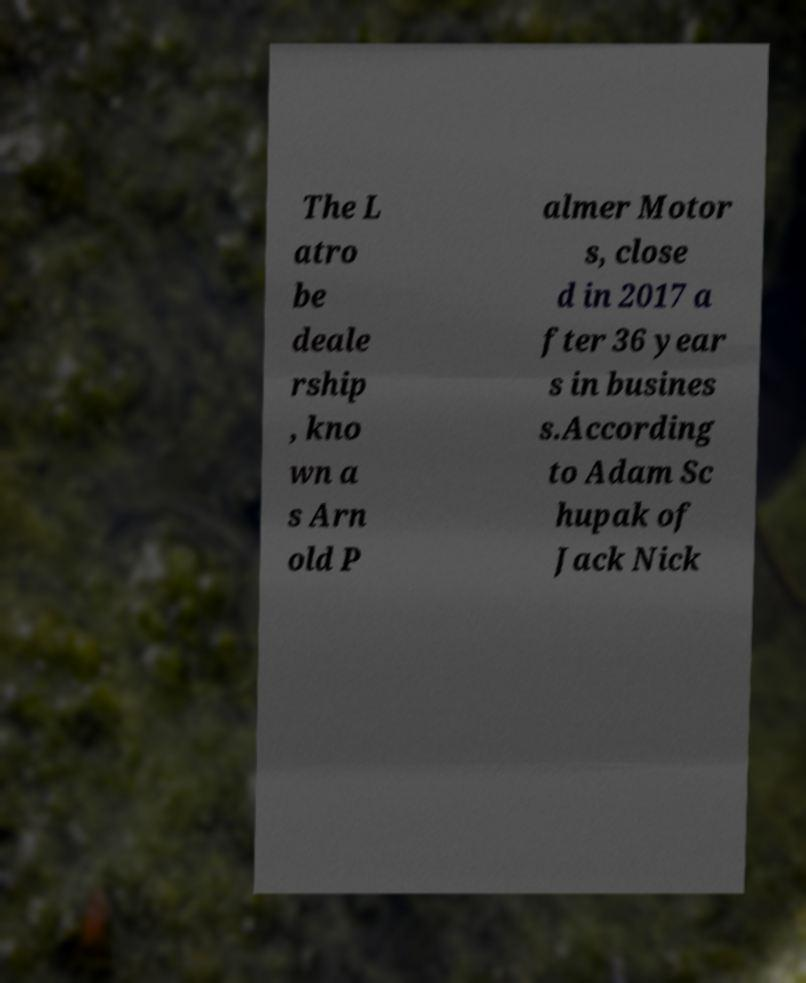For documentation purposes, I need the text within this image transcribed. Could you provide that? The L atro be deale rship , kno wn a s Arn old P almer Motor s, close d in 2017 a fter 36 year s in busines s.According to Adam Sc hupak of Jack Nick 